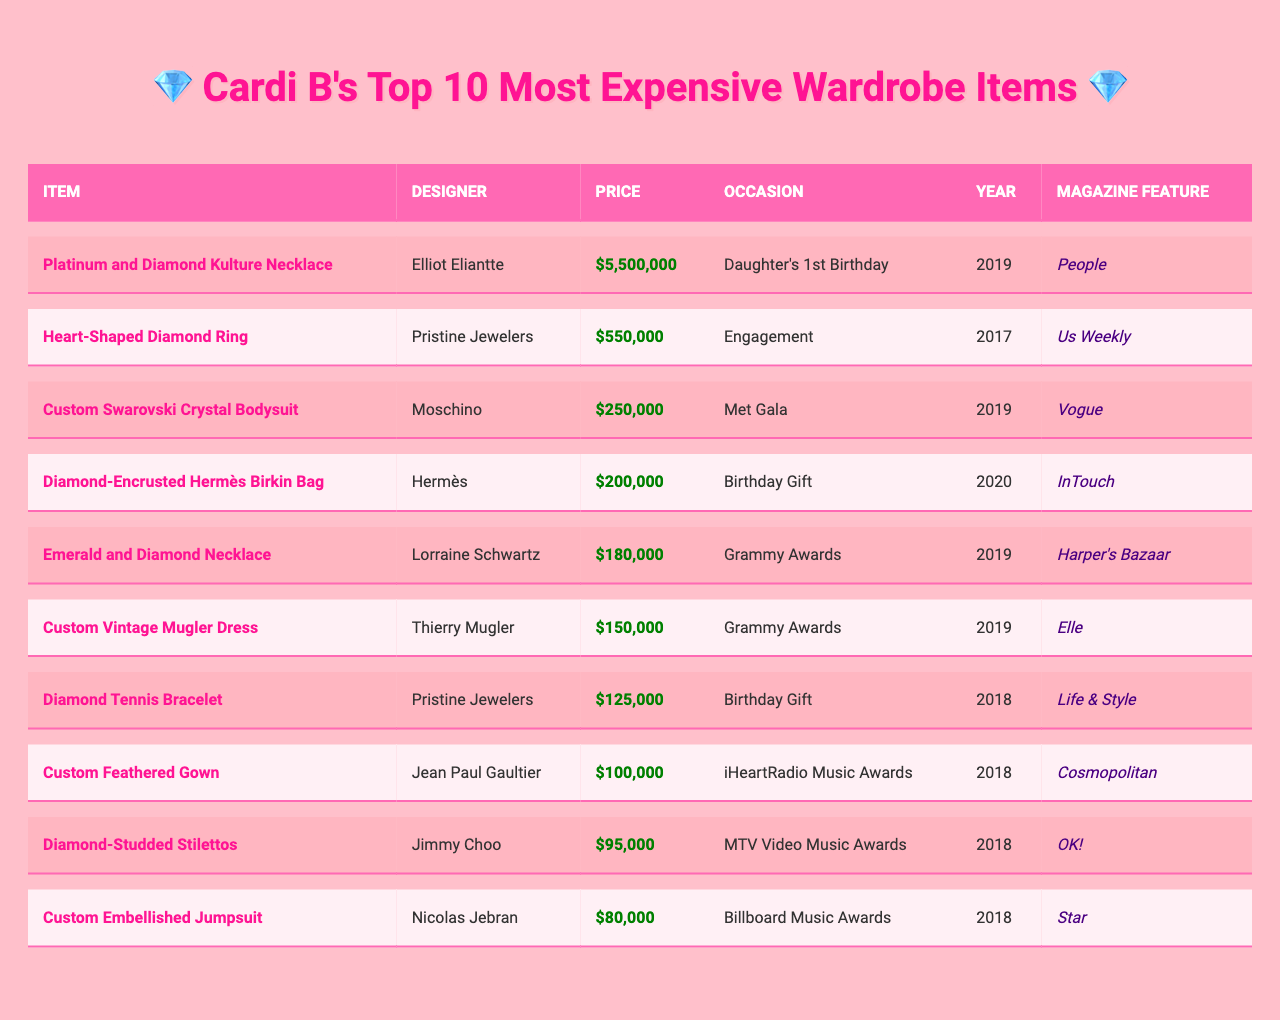What is the most expensive item in Cardi B's wardrobe? The table lists the items in order of price. The first item is the "Platinum and Diamond Kulture Necklace," which is priced at $5,500,000.
Answer: Platinum and Diamond Kulture Necklace Who designed the "Emerald and Diamond Necklace"? The table provides the designer names for each item. The "Emerald and Diamond Necklace" was designed by Lorraine Schwartz.
Answer: Lorraine Schwartz What was the occasion for the "Custom Swarovski Crystal Bodysuit"? The table shows the occasion for each item. The "Custom Swarovski Crystal Bodysuit" was worn at the Met Gala.
Answer: Met Gala How much did Cardi B spend on the "Custom Feathered Gown"? The price for the "Custom Feathered Gown" is listed in the table as $100,000.
Answer: $100,000 What is the combined price of the "Heart-Shaped Diamond Ring" and the "Diamond Tennis Bracelet"? The prices for these items are $550,000 and $125,000 respectively. Adding them gives $550,000 + $125,000 = $675,000.
Answer: $675,000 Which item was featured in "People" magazine? The table specifies the magazine features for each item. The "Platinum and Diamond Kulture Necklace" was featured in "People".
Answer: Platinum and Diamond Kulture Necklace Was any item purchased for a birthday occasion? Looking at the occasions, both the "Diamond-Encrusted Hermès Birkin Bag" and the "Diamond Tennis Bracelet" were purchased for birthdays.
Answer: Yes Identify the year when the "Custom Vintage Mugler Dress" was worn. The table indicates that the "Custom Vintage Mugler Dress" was worn in the year 2019.
Answer: 2019 What is the difference in price between the "Diamond-Studded Stilettos" and the "Custom Embellished Jumpsuit"? The price of "Diamond-Studded Stilettos" is $95,000 and "Custom Embellished Jumpsuit" is $80,000. The difference is $95,000 - $80,000 = $15,000.
Answer: $15,000 Which designer created the most expensive item and what is its price? The most expensive item is the "Platinum and Diamond Kulture Necklace" created by Elliot Eliantte, priced at $5,500,000.
Answer: Elliot Eliantte, $5,500,000 